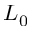<formula> <loc_0><loc_0><loc_500><loc_500>L _ { 0 }</formula> 